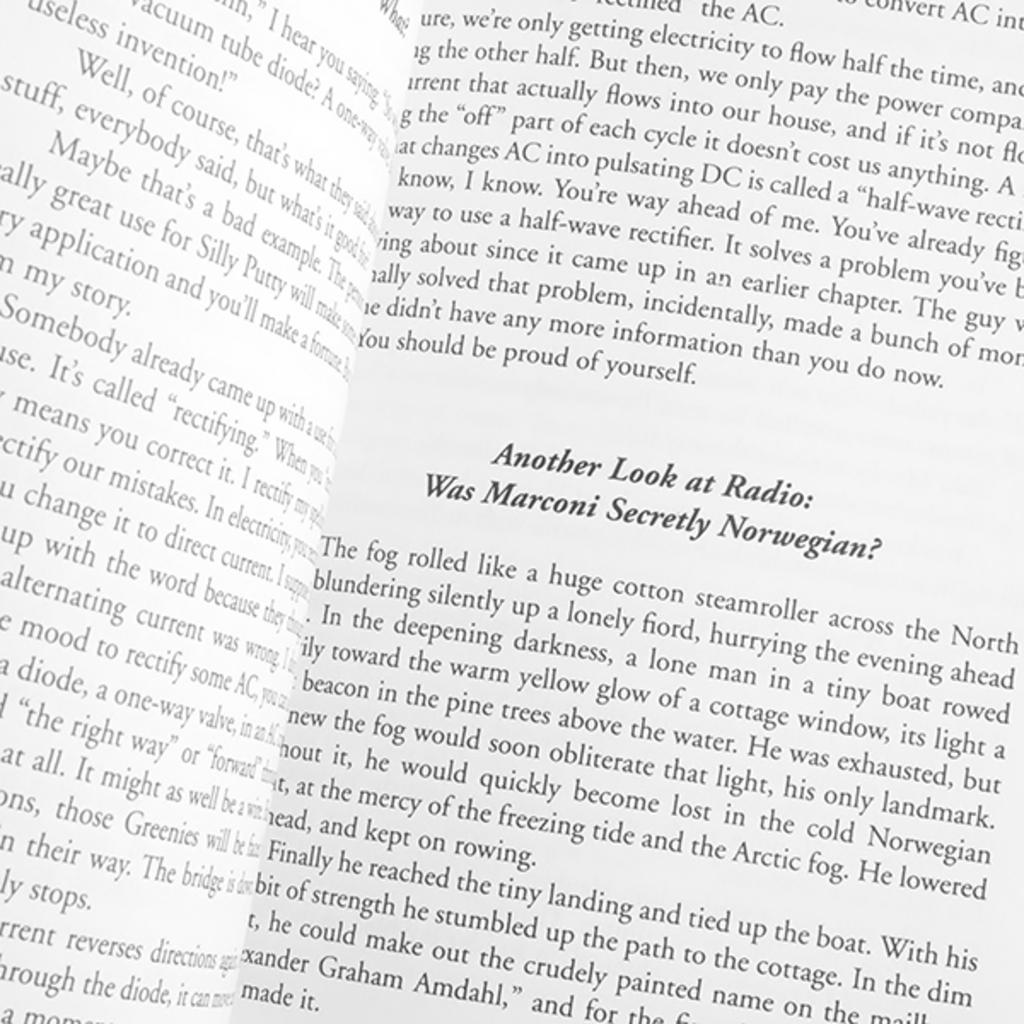<image>
Share a concise interpretation of the image provided. A book about Marconi and radio, open to questions about Marconi's heritage. 